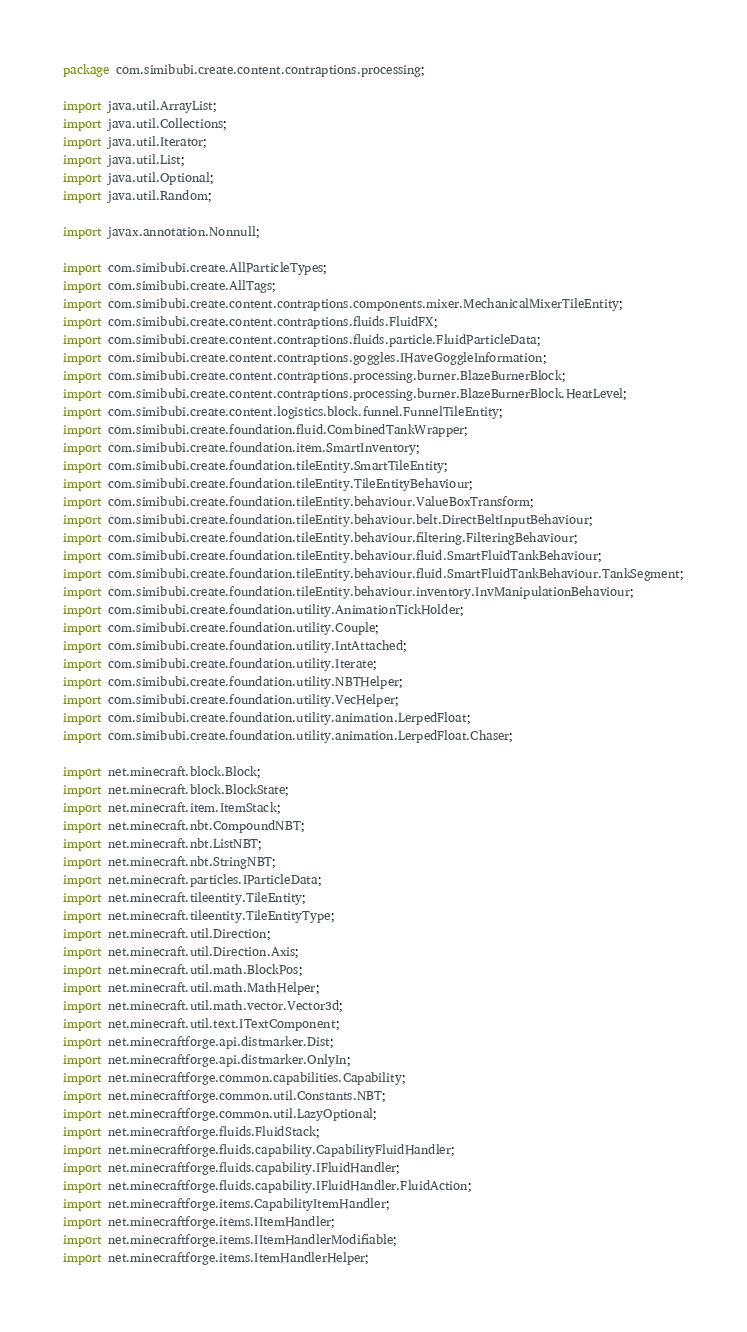Convert code to text. <code><loc_0><loc_0><loc_500><loc_500><_Java_>package com.simibubi.create.content.contraptions.processing;

import java.util.ArrayList;
import java.util.Collections;
import java.util.Iterator;
import java.util.List;
import java.util.Optional;
import java.util.Random;

import javax.annotation.Nonnull;

import com.simibubi.create.AllParticleTypes;
import com.simibubi.create.AllTags;
import com.simibubi.create.content.contraptions.components.mixer.MechanicalMixerTileEntity;
import com.simibubi.create.content.contraptions.fluids.FluidFX;
import com.simibubi.create.content.contraptions.fluids.particle.FluidParticleData;
import com.simibubi.create.content.contraptions.goggles.IHaveGoggleInformation;
import com.simibubi.create.content.contraptions.processing.burner.BlazeBurnerBlock;
import com.simibubi.create.content.contraptions.processing.burner.BlazeBurnerBlock.HeatLevel;
import com.simibubi.create.content.logistics.block.funnel.FunnelTileEntity;
import com.simibubi.create.foundation.fluid.CombinedTankWrapper;
import com.simibubi.create.foundation.item.SmartInventory;
import com.simibubi.create.foundation.tileEntity.SmartTileEntity;
import com.simibubi.create.foundation.tileEntity.TileEntityBehaviour;
import com.simibubi.create.foundation.tileEntity.behaviour.ValueBoxTransform;
import com.simibubi.create.foundation.tileEntity.behaviour.belt.DirectBeltInputBehaviour;
import com.simibubi.create.foundation.tileEntity.behaviour.filtering.FilteringBehaviour;
import com.simibubi.create.foundation.tileEntity.behaviour.fluid.SmartFluidTankBehaviour;
import com.simibubi.create.foundation.tileEntity.behaviour.fluid.SmartFluidTankBehaviour.TankSegment;
import com.simibubi.create.foundation.tileEntity.behaviour.inventory.InvManipulationBehaviour;
import com.simibubi.create.foundation.utility.AnimationTickHolder;
import com.simibubi.create.foundation.utility.Couple;
import com.simibubi.create.foundation.utility.IntAttached;
import com.simibubi.create.foundation.utility.Iterate;
import com.simibubi.create.foundation.utility.NBTHelper;
import com.simibubi.create.foundation.utility.VecHelper;
import com.simibubi.create.foundation.utility.animation.LerpedFloat;
import com.simibubi.create.foundation.utility.animation.LerpedFloat.Chaser;

import net.minecraft.block.Block;
import net.minecraft.block.BlockState;
import net.minecraft.item.ItemStack;
import net.minecraft.nbt.CompoundNBT;
import net.minecraft.nbt.ListNBT;
import net.minecraft.nbt.StringNBT;
import net.minecraft.particles.IParticleData;
import net.minecraft.tileentity.TileEntity;
import net.minecraft.tileentity.TileEntityType;
import net.minecraft.util.Direction;
import net.minecraft.util.Direction.Axis;
import net.minecraft.util.math.BlockPos;
import net.minecraft.util.math.MathHelper;
import net.minecraft.util.math.vector.Vector3d;
import net.minecraft.util.text.ITextComponent;
import net.minecraftforge.api.distmarker.Dist;
import net.minecraftforge.api.distmarker.OnlyIn;
import net.minecraftforge.common.capabilities.Capability;
import net.minecraftforge.common.util.Constants.NBT;
import net.minecraftforge.common.util.LazyOptional;
import net.minecraftforge.fluids.FluidStack;
import net.minecraftforge.fluids.capability.CapabilityFluidHandler;
import net.minecraftforge.fluids.capability.IFluidHandler;
import net.minecraftforge.fluids.capability.IFluidHandler.FluidAction;
import net.minecraftforge.items.CapabilityItemHandler;
import net.minecraftforge.items.IItemHandler;
import net.minecraftforge.items.IItemHandlerModifiable;
import net.minecraftforge.items.ItemHandlerHelper;</code> 